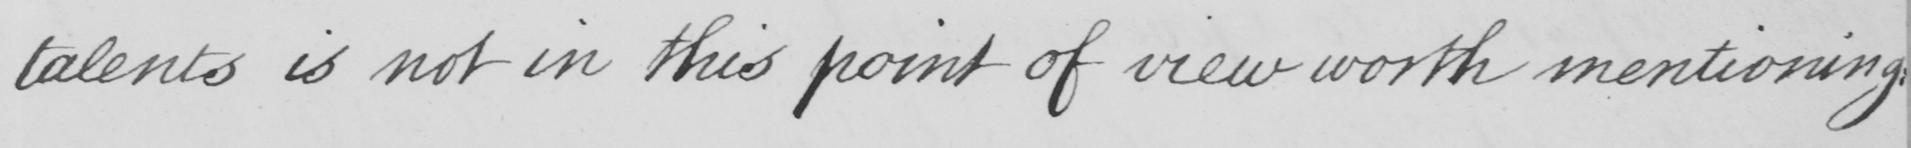Can you read and transcribe this handwriting? talents is not in this point of view worth mentioning 